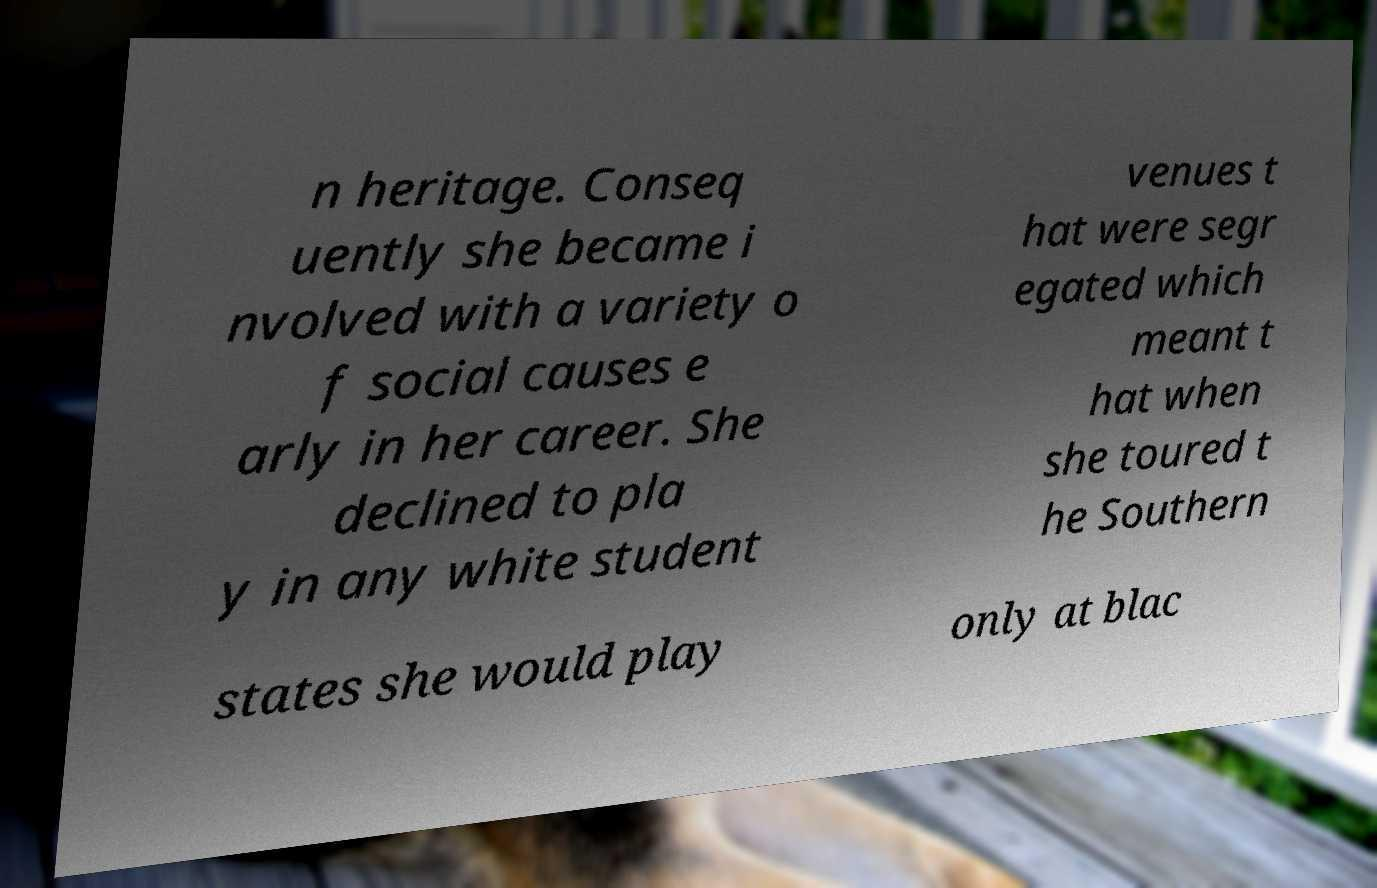I need the written content from this picture converted into text. Can you do that? n heritage. Conseq uently she became i nvolved with a variety o f social causes e arly in her career. She declined to pla y in any white student venues t hat were segr egated which meant t hat when she toured t he Southern states she would play only at blac 